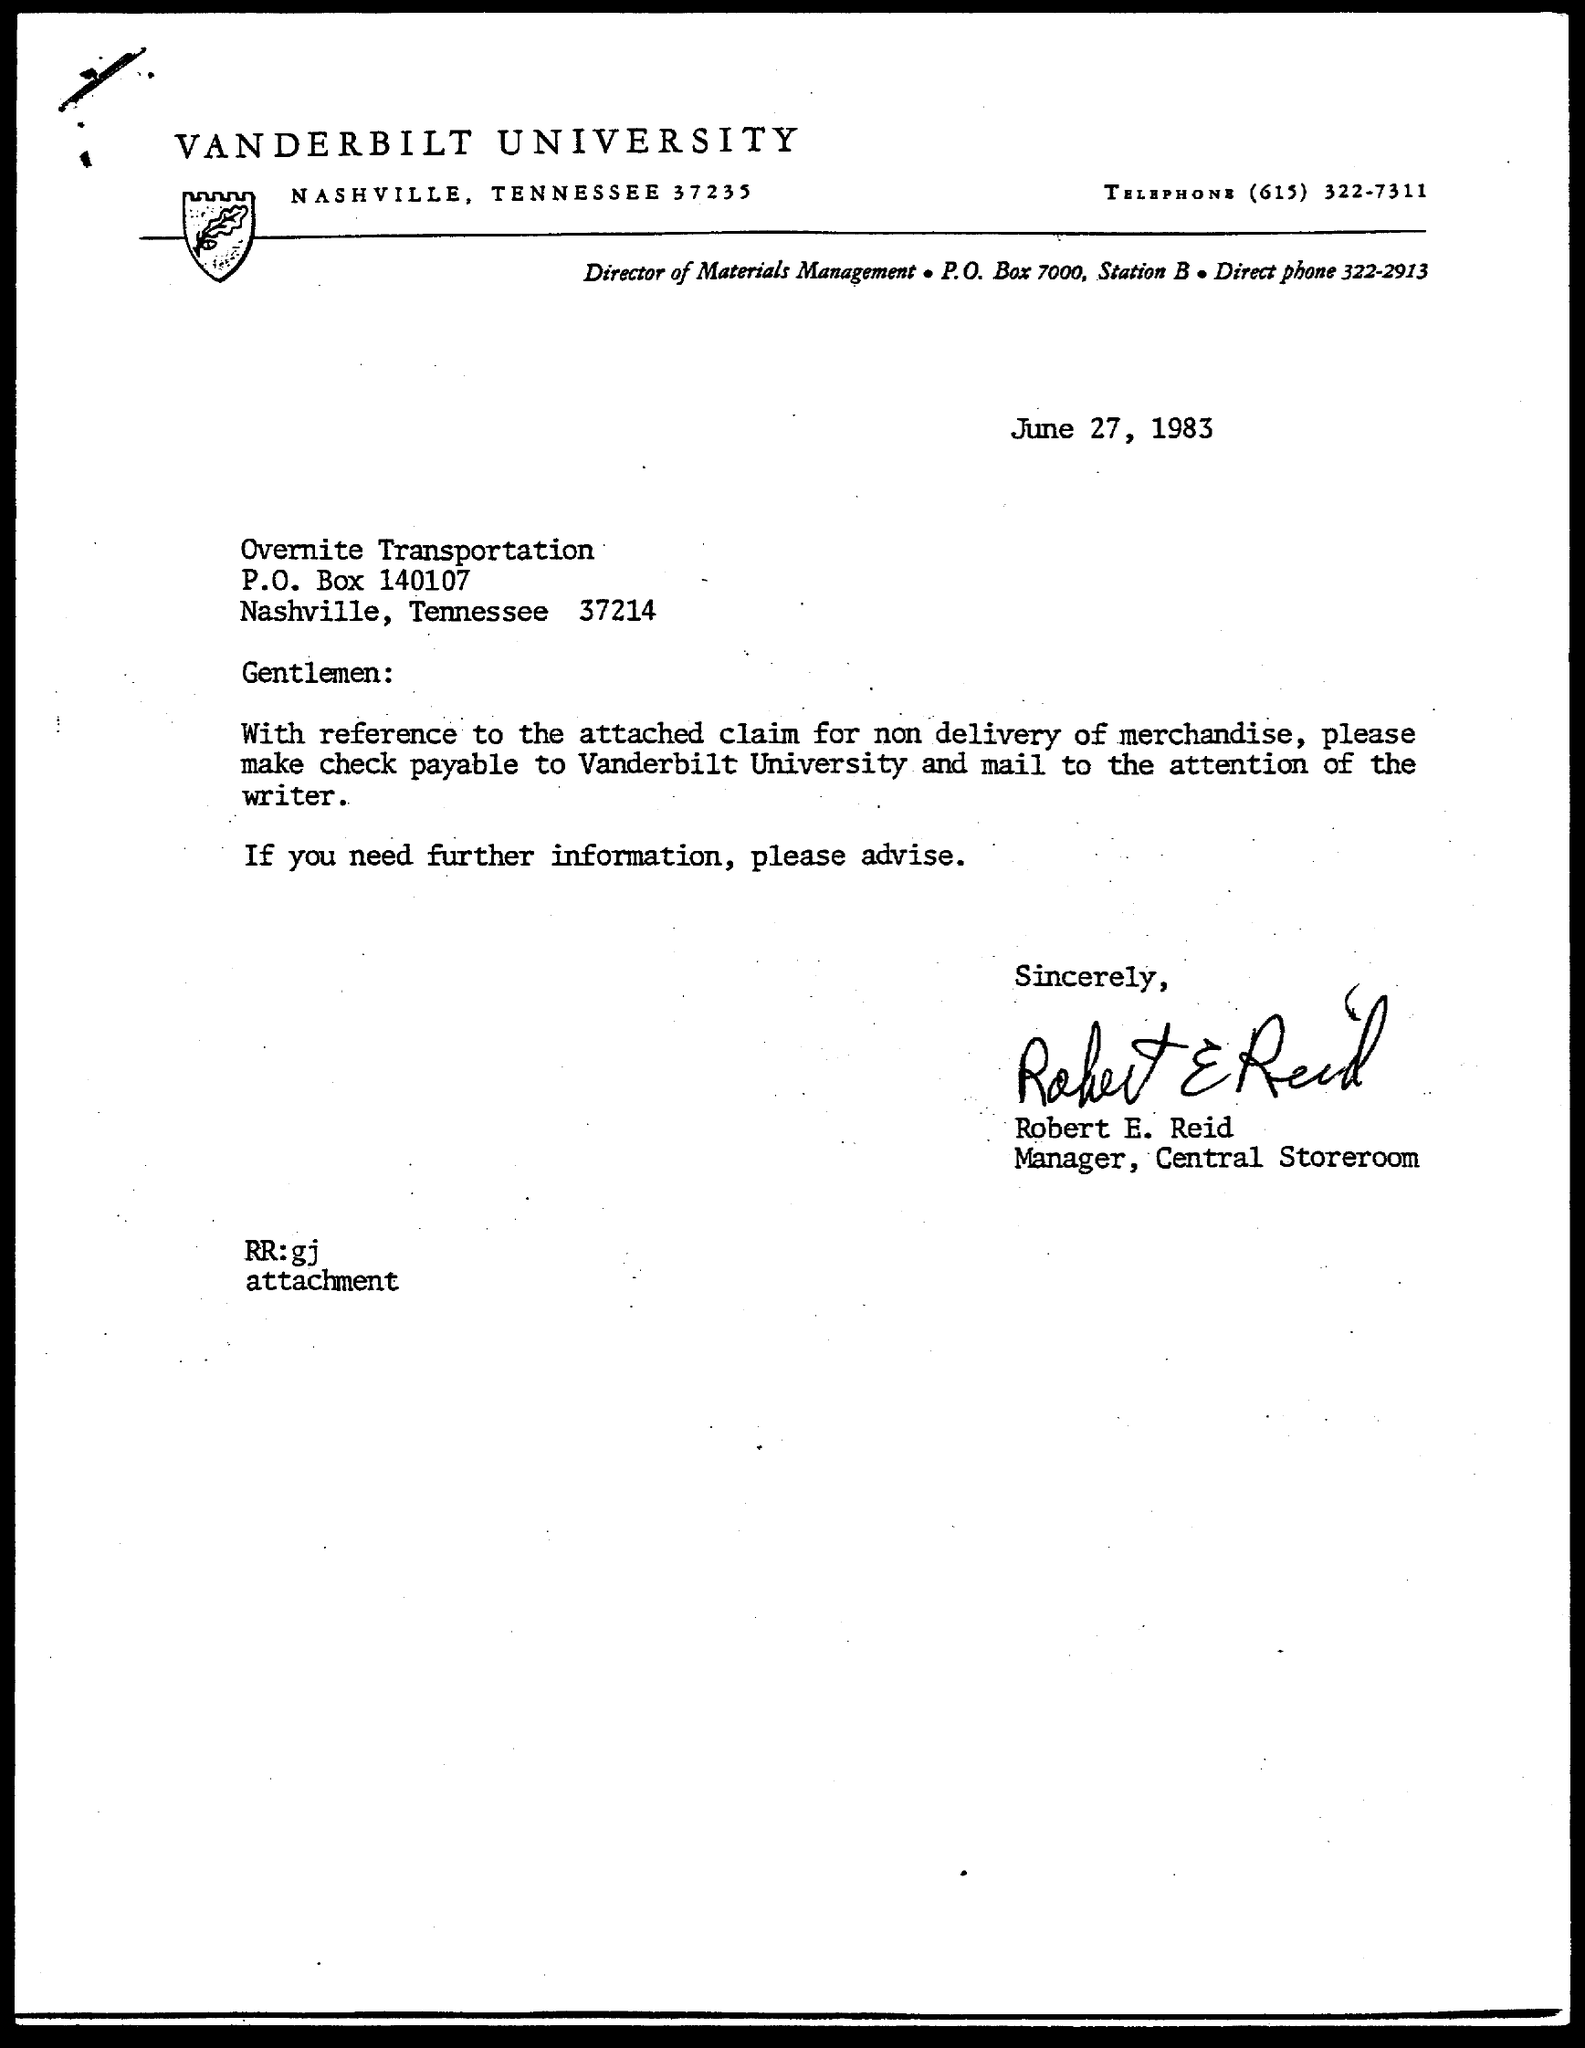Who is the Manager ?
Give a very brief answer. Robert E. Reid. 